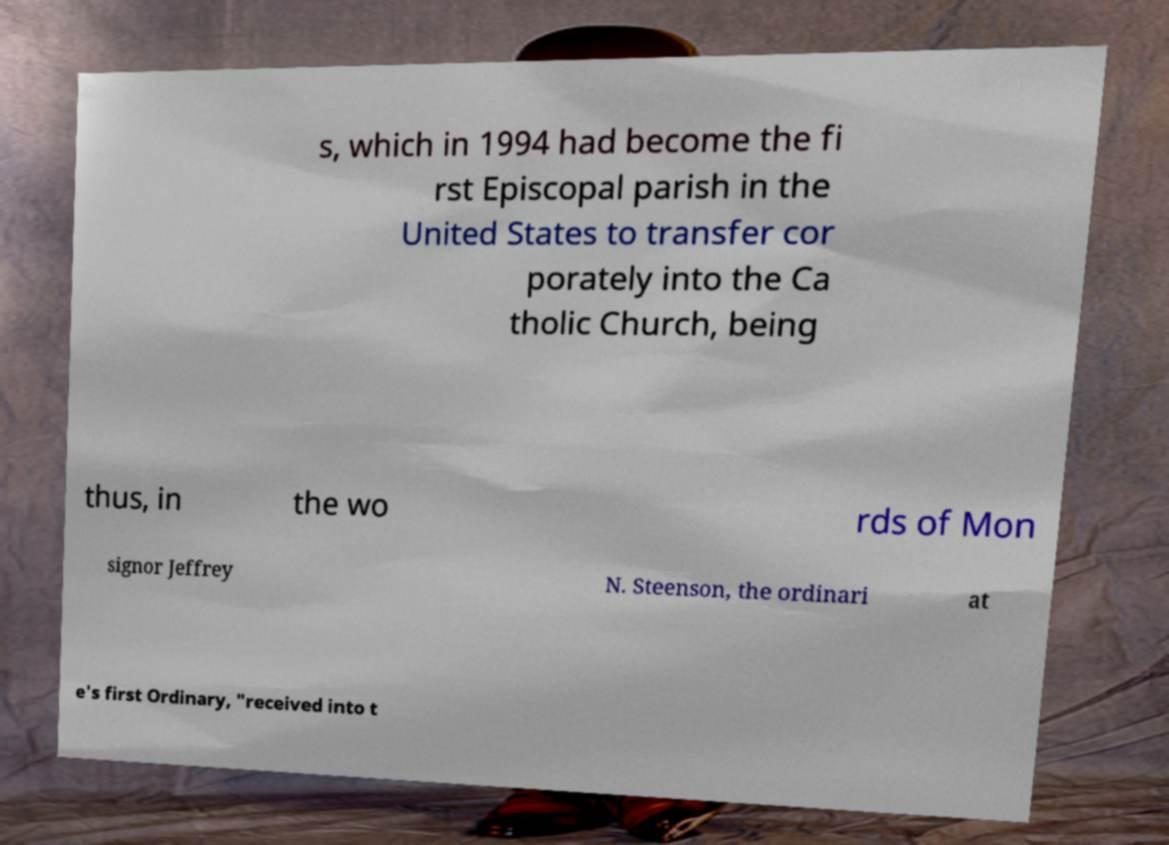Can you accurately transcribe the text from the provided image for me? s, which in 1994 had become the fi rst Episcopal parish in the United States to transfer cor porately into the Ca tholic Church, being thus, in the wo rds of Mon signor Jeffrey N. Steenson, the ordinari at e's first Ordinary, "received into t 